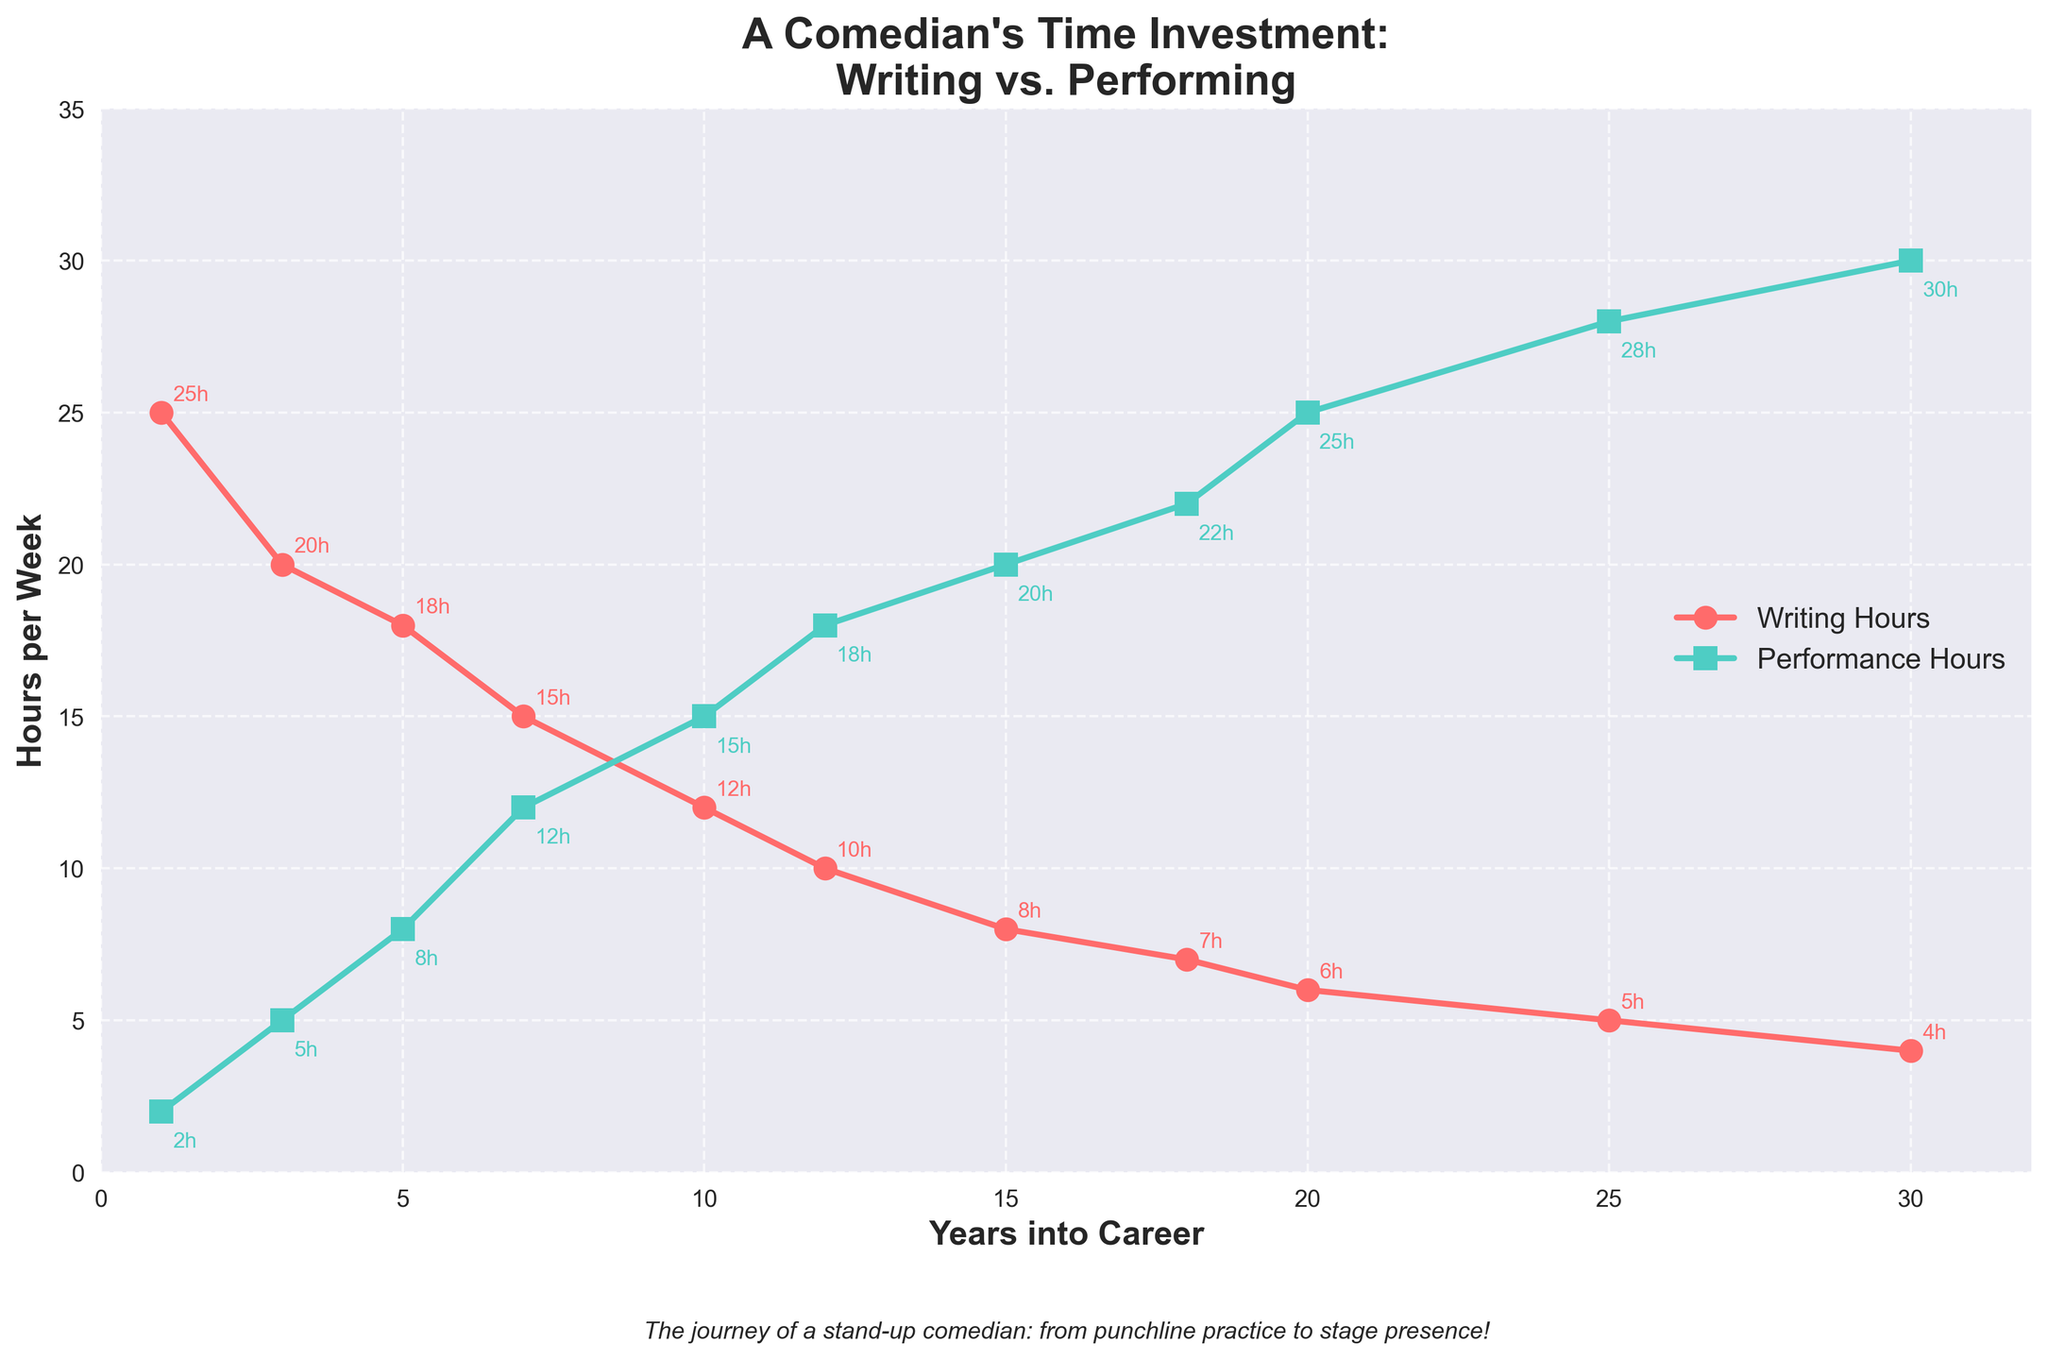What happens to the number of writing hours per week over the comedian's career? Looking at the red line, which represents writing hours, it starts at 25 hours per week at Year 1 and gradually decreases to 4 hours per week by Year 30.
Answer: It decreases Which activity does the comedian spend more time on in Year 10? By observing the data points at Year 10, the comedian spends 12 hours per week writing and 15 hours performing, so more time is spent performing.
Answer: Performing What is the gap between writing and performance hours at Year 7? At Year 7, there are 15 writing hours and 12 performance hours. So, the difference is 15 - 12.
Answer: 3 hours At which point in the career does performance time first exceed writing time? By looking at the chart, performance hours surpass writing hours between Year 5 and Year 7. Checking exact data points: 18 hours writing, 8 hours performing at Year 5; 15 hours writing, 12 hours performing at Year 7. So, it happens between these years.
Answer: Between Year 5 and Year 7 Which year sees the highest number of performance hours, and what is that number? The highest point on the green line for performance hours occurs at Year 30, with 30 hours per week.
Answer: Year 30, 30 hours What is the average number of writing hours per week during the first 10 years? Data points for first 10 years are: (25, 20, 18, 15, 12) hours. Sum is 25+20+18+15+12 = 90 hours, and average = 90/5 = 18 hours/week.
Answer: 18 hours/week Compare the trend of writing hours and performance hours over the 30 years. The writing hours (red line) consistently decrease every few years, while performance hours (green line) increase steadily over the same period of time.
Answer: Writing decreases, performing increases At Year 18, by how much do performance hours exceed writing hours? At Year 18, writing hours are 7 hours per week, and performance hours are 22 hours per week. The difference is 22 - 7.
Answer: 15 hours In which year is the number of writing hours and performance hours closest to each other? The gap is smallest where the red and green lines are closest. This appears around Year 7-10. Specifically, Year 10: writing hours = 12, performance = 15.
Answer: Year 10 Compare the increment rate of performance hours between Year 18 and Year 20. For Year 18, performance hours are 22; and at 20 years, they are 25. The increment rate is 25 - 22.
Answer: 3 hours 